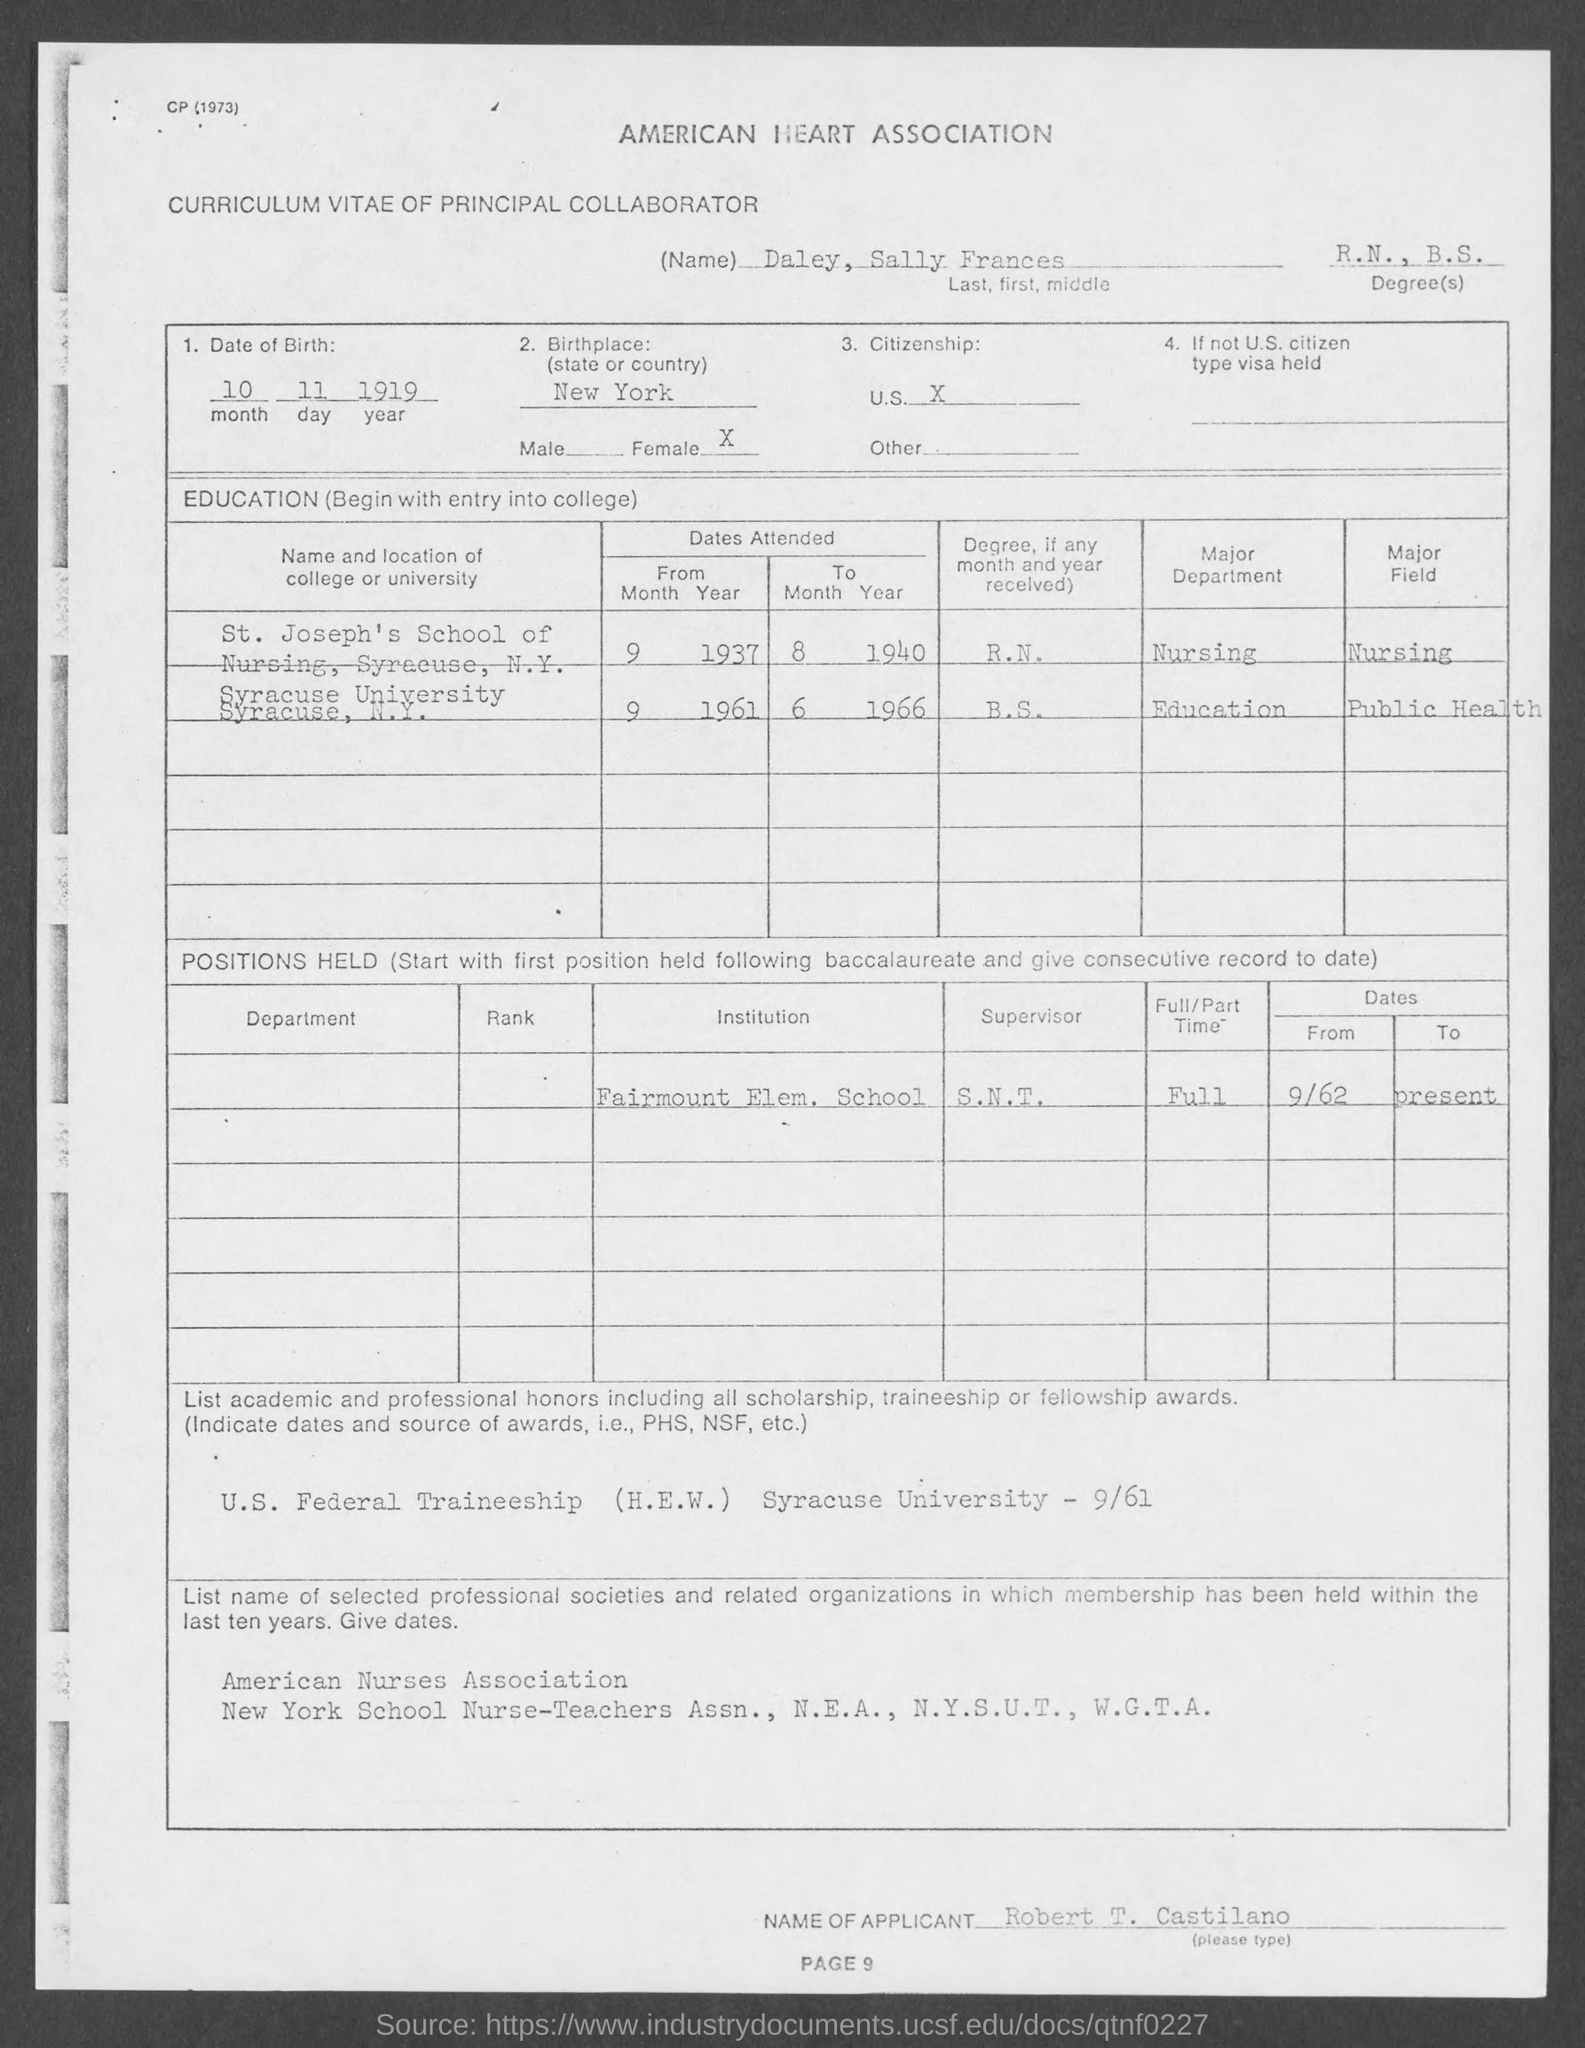What is the Title of the document?
Make the answer very short. Curriculum vitae of principal collaborator. What is the Name?
Keep it short and to the point. Daley, Sally Frances. What are the Degrees?
Ensure brevity in your answer.  R.N., B.S. What is the Date of Birth?
Make the answer very short. 10 11 1919. What is the Birthplace?
Keep it short and to the point. New york. What is the Citizenship?
Provide a short and direct response. U.S. 